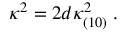Convert formula to latex. <formula><loc_0><loc_0><loc_500><loc_500>\kappa ^ { 2 } = 2 d \kappa _ { ( 1 0 ) } ^ { 2 } \, .</formula> 